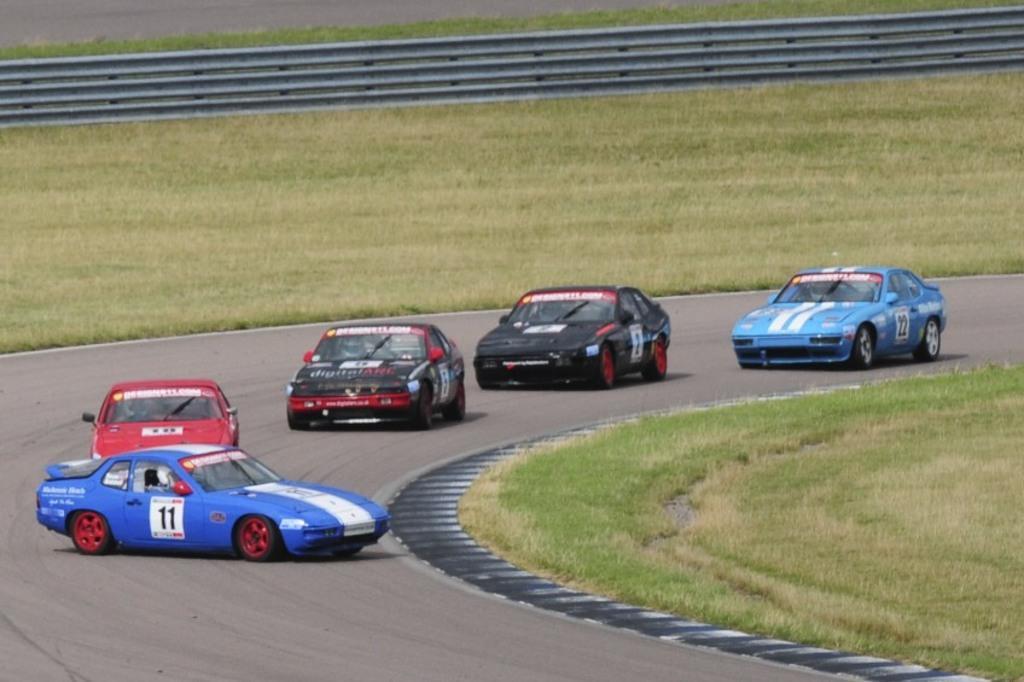Can you describe this image briefly? In the center of the image we can see cars on the road. On the right side of the image we can see a grass. In the background there is a grass and fencing. 